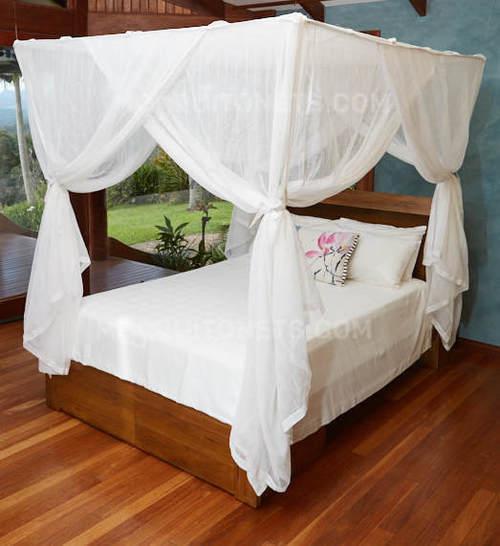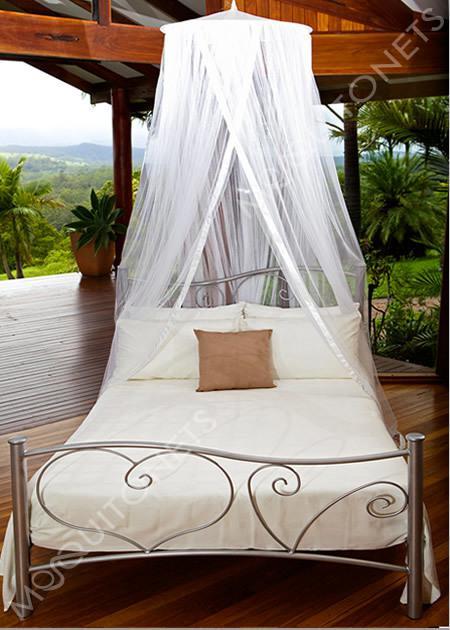The first image is the image on the left, the second image is the image on the right. Assess this claim about the two images: "In one image, gauzy bed curtains are draped from a square frame, and knotted halfway down at each corner.". Correct or not? Answer yes or no. Yes. 